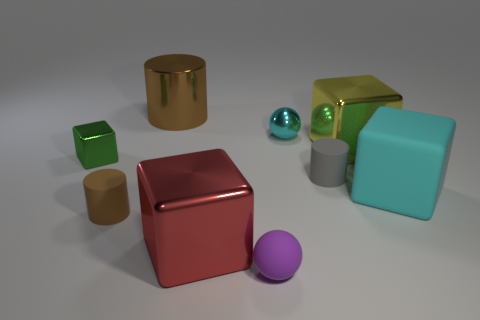Subtract all brown cylinders. How many were subtracted if there are1brown cylinders left? 1 Subtract 1 cubes. How many cubes are left? 3 Add 1 tiny brown matte cylinders. How many objects exist? 10 Subtract all blocks. How many objects are left? 5 Subtract all yellow cubes. Subtract all cyan matte cubes. How many objects are left? 7 Add 2 big things. How many big things are left? 6 Add 4 shiny objects. How many shiny objects exist? 9 Subtract 0 brown spheres. How many objects are left? 9 